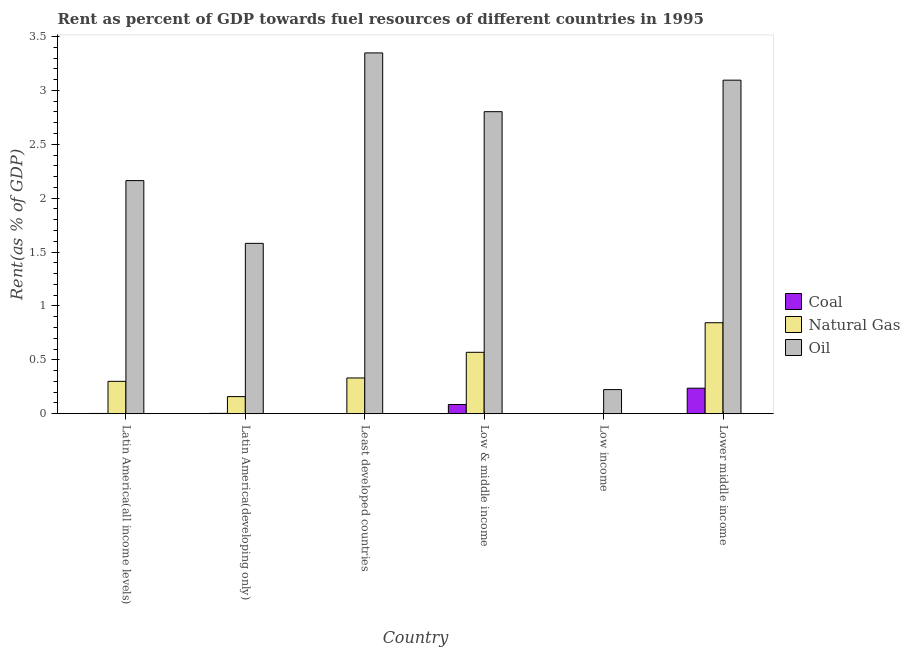How many different coloured bars are there?
Provide a short and direct response. 3. Are the number of bars on each tick of the X-axis equal?
Give a very brief answer. Yes. What is the rent towards coal in Latin America(all income levels)?
Give a very brief answer. 0. Across all countries, what is the maximum rent towards coal?
Your response must be concise. 0.24. Across all countries, what is the minimum rent towards natural gas?
Offer a very short reply. 3.1650228781704e-5. In which country was the rent towards coal maximum?
Provide a short and direct response. Lower middle income. What is the total rent towards oil in the graph?
Your answer should be compact. 13.21. What is the difference between the rent towards natural gas in Latin America(developing only) and that in Least developed countries?
Offer a very short reply. -0.17. What is the difference between the rent towards natural gas in Lower middle income and the rent towards coal in Latin America(developing only)?
Provide a succinct answer. 0.84. What is the average rent towards oil per country?
Ensure brevity in your answer.  2.2. What is the difference between the rent towards natural gas and rent towards coal in Low & middle income?
Provide a succinct answer. 0.48. What is the ratio of the rent towards oil in Latin America(all income levels) to that in Low & middle income?
Your response must be concise. 0.77. Is the difference between the rent towards coal in Latin America(all income levels) and Least developed countries greater than the difference between the rent towards oil in Latin America(all income levels) and Least developed countries?
Your response must be concise. Yes. What is the difference between the highest and the second highest rent towards oil?
Make the answer very short. 0.25. What is the difference between the highest and the lowest rent towards natural gas?
Offer a very short reply. 0.84. In how many countries, is the rent towards oil greater than the average rent towards oil taken over all countries?
Give a very brief answer. 3. What does the 3rd bar from the left in Latin America(all income levels) represents?
Give a very brief answer. Oil. What does the 1st bar from the right in Least developed countries represents?
Offer a very short reply. Oil. How many bars are there?
Your answer should be very brief. 18. How many countries are there in the graph?
Make the answer very short. 6. What is the difference between two consecutive major ticks on the Y-axis?
Provide a short and direct response. 0.5. Are the values on the major ticks of Y-axis written in scientific E-notation?
Provide a short and direct response. No. Does the graph contain any zero values?
Offer a terse response. No. Does the graph contain grids?
Your response must be concise. No. How many legend labels are there?
Your answer should be compact. 3. What is the title of the graph?
Your response must be concise. Rent as percent of GDP towards fuel resources of different countries in 1995. What is the label or title of the Y-axis?
Your response must be concise. Rent(as % of GDP). What is the Rent(as % of GDP) in Coal in Latin America(all income levels)?
Make the answer very short. 0. What is the Rent(as % of GDP) in Natural Gas in Latin America(all income levels)?
Provide a short and direct response. 0.3. What is the Rent(as % of GDP) in Oil in Latin America(all income levels)?
Give a very brief answer. 2.16. What is the Rent(as % of GDP) of Coal in Latin America(developing only)?
Give a very brief answer. 0. What is the Rent(as % of GDP) in Natural Gas in Latin America(developing only)?
Ensure brevity in your answer.  0.16. What is the Rent(as % of GDP) in Oil in Latin America(developing only)?
Provide a short and direct response. 1.58. What is the Rent(as % of GDP) of Coal in Least developed countries?
Keep it short and to the point. 0. What is the Rent(as % of GDP) of Natural Gas in Least developed countries?
Keep it short and to the point. 0.33. What is the Rent(as % of GDP) of Oil in Least developed countries?
Your answer should be compact. 3.35. What is the Rent(as % of GDP) of Coal in Low & middle income?
Keep it short and to the point. 0.09. What is the Rent(as % of GDP) of Natural Gas in Low & middle income?
Your answer should be very brief. 0.57. What is the Rent(as % of GDP) in Oil in Low & middle income?
Ensure brevity in your answer.  2.8. What is the Rent(as % of GDP) of Coal in Low income?
Provide a short and direct response. 0. What is the Rent(as % of GDP) of Natural Gas in Low income?
Offer a terse response. 3.1650228781704e-5. What is the Rent(as % of GDP) in Oil in Low income?
Ensure brevity in your answer.  0.22. What is the Rent(as % of GDP) in Coal in Lower middle income?
Ensure brevity in your answer.  0.24. What is the Rent(as % of GDP) in Natural Gas in Lower middle income?
Give a very brief answer. 0.84. What is the Rent(as % of GDP) of Oil in Lower middle income?
Ensure brevity in your answer.  3.1. Across all countries, what is the maximum Rent(as % of GDP) of Coal?
Keep it short and to the point. 0.24. Across all countries, what is the maximum Rent(as % of GDP) of Natural Gas?
Your response must be concise. 0.84. Across all countries, what is the maximum Rent(as % of GDP) in Oil?
Your response must be concise. 3.35. Across all countries, what is the minimum Rent(as % of GDP) in Coal?
Give a very brief answer. 0. Across all countries, what is the minimum Rent(as % of GDP) in Natural Gas?
Your answer should be compact. 3.1650228781704e-5. Across all countries, what is the minimum Rent(as % of GDP) in Oil?
Keep it short and to the point. 0.22. What is the total Rent(as % of GDP) in Coal in the graph?
Provide a short and direct response. 0.33. What is the total Rent(as % of GDP) in Natural Gas in the graph?
Offer a very short reply. 2.21. What is the total Rent(as % of GDP) in Oil in the graph?
Give a very brief answer. 13.21. What is the difference between the Rent(as % of GDP) in Coal in Latin America(all income levels) and that in Latin America(developing only)?
Your response must be concise. -0. What is the difference between the Rent(as % of GDP) of Natural Gas in Latin America(all income levels) and that in Latin America(developing only)?
Provide a short and direct response. 0.14. What is the difference between the Rent(as % of GDP) in Oil in Latin America(all income levels) and that in Latin America(developing only)?
Keep it short and to the point. 0.58. What is the difference between the Rent(as % of GDP) in Coal in Latin America(all income levels) and that in Least developed countries?
Provide a short and direct response. 0. What is the difference between the Rent(as % of GDP) in Natural Gas in Latin America(all income levels) and that in Least developed countries?
Your answer should be compact. -0.03. What is the difference between the Rent(as % of GDP) in Oil in Latin America(all income levels) and that in Least developed countries?
Provide a short and direct response. -1.18. What is the difference between the Rent(as % of GDP) of Coal in Latin America(all income levels) and that in Low & middle income?
Your answer should be very brief. -0.08. What is the difference between the Rent(as % of GDP) of Natural Gas in Latin America(all income levels) and that in Low & middle income?
Offer a terse response. -0.27. What is the difference between the Rent(as % of GDP) of Oil in Latin America(all income levels) and that in Low & middle income?
Your response must be concise. -0.64. What is the difference between the Rent(as % of GDP) of Coal in Latin America(all income levels) and that in Low income?
Your answer should be compact. 0. What is the difference between the Rent(as % of GDP) in Natural Gas in Latin America(all income levels) and that in Low income?
Give a very brief answer. 0.3. What is the difference between the Rent(as % of GDP) in Oil in Latin America(all income levels) and that in Low income?
Make the answer very short. 1.94. What is the difference between the Rent(as % of GDP) of Coal in Latin America(all income levels) and that in Lower middle income?
Give a very brief answer. -0.23. What is the difference between the Rent(as % of GDP) of Natural Gas in Latin America(all income levels) and that in Lower middle income?
Provide a short and direct response. -0.54. What is the difference between the Rent(as % of GDP) in Oil in Latin America(all income levels) and that in Lower middle income?
Provide a succinct answer. -0.93. What is the difference between the Rent(as % of GDP) in Coal in Latin America(developing only) and that in Least developed countries?
Your answer should be very brief. 0. What is the difference between the Rent(as % of GDP) of Natural Gas in Latin America(developing only) and that in Least developed countries?
Your response must be concise. -0.17. What is the difference between the Rent(as % of GDP) of Oil in Latin America(developing only) and that in Least developed countries?
Offer a terse response. -1.77. What is the difference between the Rent(as % of GDP) in Coal in Latin America(developing only) and that in Low & middle income?
Make the answer very short. -0.08. What is the difference between the Rent(as % of GDP) of Natural Gas in Latin America(developing only) and that in Low & middle income?
Ensure brevity in your answer.  -0.41. What is the difference between the Rent(as % of GDP) in Oil in Latin America(developing only) and that in Low & middle income?
Your answer should be compact. -1.22. What is the difference between the Rent(as % of GDP) in Coal in Latin America(developing only) and that in Low income?
Provide a short and direct response. 0. What is the difference between the Rent(as % of GDP) in Natural Gas in Latin America(developing only) and that in Low income?
Provide a succinct answer. 0.16. What is the difference between the Rent(as % of GDP) of Oil in Latin America(developing only) and that in Low income?
Your answer should be compact. 1.36. What is the difference between the Rent(as % of GDP) in Coal in Latin America(developing only) and that in Lower middle income?
Keep it short and to the point. -0.23. What is the difference between the Rent(as % of GDP) in Natural Gas in Latin America(developing only) and that in Lower middle income?
Give a very brief answer. -0.69. What is the difference between the Rent(as % of GDP) in Oil in Latin America(developing only) and that in Lower middle income?
Offer a very short reply. -1.51. What is the difference between the Rent(as % of GDP) of Coal in Least developed countries and that in Low & middle income?
Your answer should be very brief. -0.09. What is the difference between the Rent(as % of GDP) in Natural Gas in Least developed countries and that in Low & middle income?
Offer a very short reply. -0.24. What is the difference between the Rent(as % of GDP) in Oil in Least developed countries and that in Low & middle income?
Keep it short and to the point. 0.55. What is the difference between the Rent(as % of GDP) in Coal in Least developed countries and that in Low income?
Keep it short and to the point. -0. What is the difference between the Rent(as % of GDP) of Natural Gas in Least developed countries and that in Low income?
Make the answer very short. 0.33. What is the difference between the Rent(as % of GDP) in Oil in Least developed countries and that in Low income?
Ensure brevity in your answer.  3.12. What is the difference between the Rent(as % of GDP) of Coal in Least developed countries and that in Lower middle income?
Your answer should be very brief. -0.24. What is the difference between the Rent(as % of GDP) of Natural Gas in Least developed countries and that in Lower middle income?
Your answer should be very brief. -0.51. What is the difference between the Rent(as % of GDP) in Oil in Least developed countries and that in Lower middle income?
Offer a terse response. 0.25. What is the difference between the Rent(as % of GDP) of Coal in Low & middle income and that in Low income?
Keep it short and to the point. 0.08. What is the difference between the Rent(as % of GDP) in Natural Gas in Low & middle income and that in Low income?
Ensure brevity in your answer.  0.57. What is the difference between the Rent(as % of GDP) in Oil in Low & middle income and that in Low income?
Provide a short and direct response. 2.58. What is the difference between the Rent(as % of GDP) in Coal in Low & middle income and that in Lower middle income?
Offer a very short reply. -0.15. What is the difference between the Rent(as % of GDP) in Natural Gas in Low & middle income and that in Lower middle income?
Provide a succinct answer. -0.27. What is the difference between the Rent(as % of GDP) in Oil in Low & middle income and that in Lower middle income?
Make the answer very short. -0.29. What is the difference between the Rent(as % of GDP) of Coal in Low income and that in Lower middle income?
Provide a succinct answer. -0.24. What is the difference between the Rent(as % of GDP) of Natural Gas in Low income and that in Lower middle income?
Give a very brief answer. -0.84. What is the difference between the Rent(as % of GDP) of Oil in Low income and that in Lower middle income?
Offer a terse response. -2.87. What is the difference between the Rent(as % of GDP) of Coal in Latin America(all income levels) and the Rent(as % of GDP) of Natural Gas in Latin America(developing only)?
Your response must be concise. -0.16. What is the difference between the Rent(as % of GDP) of Coal in Latin America(all income levels) and the Rent(as % of GDP) of Oil in Latin America(developing only)?
Offer a very short reply. -1.58. What is the difference between the Rent(as % of GDP) in Natural Gas in Latin America(all income levels) and the Rent(as % of GDP) in Oil in Latin America(developing only)?
Give a very brief answer. -1.28. What is the difference between the Rent(as % of GDP) of Coal in Latin America(all income levels) and the Rent(as % of GDP) of Natural Gas in Least developed countries?
Provide a short and direct response. -0.33. What is the difference between the Rent(as % of GDP) in Coal in Latin America(all income levels) and the Rent(as % of GDP) in Oil in Least developed countries?
Provide a succinct answer. -3.35. What is the difference between the Rent(as % of GDP) in Natural Gas in Latin America(all income levels) and the Rent(as % of GDP) in Oil in Least developed countries?
Give a very brief answer. -3.05. What is the difference between the Rent(as % of GDP) in Coal in Latin America(all income levels) and the Rent(as % of GDP) in Natural Gas in Low & middle income?
Provide a short and direct response. -0.57. What is the difference between the Rent(as % of GDP) of Coal in Latin America(all income levels) and the Rent(as % of GDP) of Oil in Low & middle income?
Provide a succinct answer. -2.8. What is the difference between the Rent(as % of GDP) of Natural Gas in Latin America(all income levels) and the Rent(as % of GDP) of Oil in Low & middle income?
Your answer should be compact. -2.5. What is the difference between the Rent(as % of GDP) in Coal in Latin America(all income levels) and the Rent(as % of GDP) in Natural Gas in Low income?
Your response must be concise. 0. What is the difference between the Rent(as % of GDP) in Coal in Latin America(all income levels) and the Rent(as % of GDP) in Oil in Low income?
Ensure brevity in your answer.  -0.22. What is the difference between the Rent(as % of GDP) of Natural Gas in Latin America(all income levels) and the Rent(as % of GDP) of Oil in Low income?
Your response must be concise. 0.08. What is the difference between the Rent(as % of GDP) in Coal in Latin America(all income levels) and the Rent(as % of GDP) in Natural Gas in Lower middle income?
Provide a succinct answer. -0.84. What is the difference between the Rent(as % of GDP) in Coal in Latin America(all income levels) and the Rent(as % of GDP) in Oil in Lower middle income?
Ensure brevity in your answer.  -3.09. What is the difference between the Rent(as % of GDP) of Natural Gas in Latin America(all income levels) and the Rent(as % of GDP) of Oil in Lower middle income?
Offer a terse response. -2.79. What is the difference between the Rent(as % of GDP) in Coal in Latin America(developing only) and the Rent(as % of GDP) in Natural Gas in Least developed countries?
Ensure brevity in your answer.  -0.33. What is the difference between the Rent(as % of GDP) in Coal in Latin America(developing only) and the Rent(as % of GDP) in Oil in Least developed countries?
Offer a terse response. -3.34. What is the difference between the Rent(as % of GDP) of Natural Gas in Latin America(developing only) and the Rent(as % of GDP) of Oil in Least developed countries?
Keep it short and to the point. -3.19. What is the difference between the Rent(as % of GDP) in Coal in Latin America(developing only) and the Rent(as % of GDP) in Natural Gas in Low & middle income?
Provide a succinct answer. -0.57. What is the difference between the Rent(as % of GDP) of Coal in Latin America(developing only) and the Rent(as % of GDP) of Oil in Low & middle income?
Offer a very short reply. -2.8. What is the difference between the Rent(as % of GDP) in Natural Gas in Latin America(developing only) and the Rent(as % of GDP) in Oil in Low & middle income?
Offer a terse response. -2.64. What is the difference between the Rent(as % of GDP) in Coal in Latin America(developing only) and the Rent(as % of GDP) in Natural Gas in Low income?
Ensure brevity in your answer.  0. What is the difference between the Rent(as % of GDP) of Coal in Latin America(developing only) and the Rent(as % of GDP) of Oil in Low income?
Your answer should be very brief. -0.22. What is the difference between the Rent(as % of GDP) of Natural Gas in Latin America(developing only) and the Rent(as % of GDP) of Oil in Low income?
Your response must be concise. -0.06. What is the difference between the Rent(as % of GDP) of Coal in Latin America(developing only) and the Rent(as % of GDP) of Natural Gas in Lower middle income?
Make the answer very short. -0.84. What is the difference between the Rent(as % of GDP) of Coal in Latin America(developing only) and the Rent(as % of GDP) of Oil in Lower middle income?
Your answer should be compact. -3.09. What is the difference between the Rent(as % of GDP) in Natural Gas in Latin America(developing only) and the Rent(as % of GDP) in Oil in Lower middle income?
Offer a terse response. -2.94. What is the difference between the Rent(as % of GDP) in Coal in Least developed countries and the Rent(as % of GDP) in Natural Gas in Low & middle income?
Provide a short and direct response. -0.57. What is the difference between the Rent(as % of GDP) of Coal in Least developed countries and the Rent(as % of GDP) of Oil in Low & middle income?
Your response must be concise. -2.8. What is the difference between the Rent(as % of GDP) of Natural Gas in Least developed countries and the Rent(as % of GDP) of Oil in Low & middle income?
Make the answer very short. -2.47. What is the difference between the Rent(as % of GDP) in Coal in Least developed countries and the Rent(as % of GDP) in Natural Gas in Low income?
Your response must be concise. 0. What is the difference between the Rent(as % of GDP) in Coal in Least developed countries and the Rent(as % of GDP) in Oil in Low income?
Your response must be concise. -0.22. What is the difference between the Rent(as % of GDP) in Natural Gas in Least developed countries and the Rent(as % of GDP) in Oil in Low income?
Your answer should be very brief. 0.11. What is the difference between the Rent(as % of GDP) in Coal in Least developed countries and the Rent(as % of GDP) in Natural Gas in Lower middle income?
Provide a succinct answer. -0.84. What is the difference between the Rent(as % of GDP) in Coal in Least developed countries and the Rent(as % of GDP) in Oil in Lower middle income?
Ensure brevity in your answer.  -3.09. What is the difference between the Rent(as % of GDP) of Natural Gas in Least developed countries and the Rent(as % of GDP) of Oil in Lower middle income?
Your answer should be very brief. -2.76. What is the difference between the Rent(as % of GDP) in Coal in Low & middle income and the Rent(as % of GDP) in Natural Gas in Low income?
Ensure brevity in your answer.  0.09. What is the difference between the Rent(as % of GDP) in Coal in Low & middle income and the Rent(as % of GDP) in Oil in Low income?
Provide a succinct answer. -0.14. What is the difference between the Rent(as % of GDP) in Natural Gas in Low & middle income and the Rent(as % of GDP) in Oil in Low income?
Make the answer very short. 0.35. What is the difference between the Rent(as % of GDP) of Coal in Low & middle income and the Rent(as % of GDP) of Natural Gas in Lower middle income?
Your response must be concise. -0.76. What is the difference between the Rent(as % of GDP) of Coal in Low & middle income and the Rent(as % of GDP) of Oil in Lower middle income?
Provide a succinct answer. -3.01. What is the difference between the Rent(as % of GDP) of Natural Gas in Low & middle income and the Rent(as % of GDP) of Oil in Lower middle income?
Make the answer very short. -2.53. What is the difference between the Rent(as % of GDP) in Coal in Low income and the Rent(as % of GDP) in Natural Gas in Lower middle income?
Offer a very short reply. -0.84. What is the difference between the Rent(as % of GDP) of Coal in Low income and the Rent(as % of GDP) of Oil in Lower middle income?
Give a very brief answer. -3.09. What is the difference between the Rent(as % of GDP) of Natural Gas in Low income and the Rent(as % of GDP) of Oil in Lower middle income?
Ensure brevity in your answer.  -3.1. What is the average Rent(as % of GDP) of Coal per country?
Your answer should be compact. 0.06. What is the average Rent(as % of GDP) of Natural Gas per country?
Make the answer very short. 0.37. What is the average Rent(as % of GDP) of Oil per country?
Make the answer very short. 2.2. What is the difference between the Rent(as % of GDP) of Coal and Rent(as % of GDP) of Natural Gas in Latin America(all income levels)?
Your response must be concise. -0.3. What is the difference between the Rent(as % of GDP) in Coal and Rent(as % of GDP) in Oil in Latin America(all income levels)?
Your response must be concise. -2.16. What is the difference between the Rent(as % of GDP) in Natural Gas and Rent(as % of GDP) in Oil in Latin America(all income levels)?
Give a very brief answer. -1.86. What is the difference between the Rent(as % of GDP) of Coal and Rent(as % of GDP) of Natural Gas in Latin America(developing only)?
Make the answer very short. -0.16. What is the difference between the Rent(as % of GDP) of Coal and Rent(as % of GDP) of Oil in Latin America(developing only)?
Offer a very short reply. -1.58. What is the difference between the Rent(as % of GDP) in Natural Gas and Rent(as % of GDP) in Oil in Latin America(developing only)?
Provide a succinct answer. -1.42. What is the difference between the Rent(as % of GDP) in Coal and Rent(as % of GDP) in Natural Gas in Least developed countries?
Offer a very short reply. -0.33. What is the difference between the Rent(as % of GDP) in Coal and Rent(as % of GDP) in Oil in Least developed countries?
Offer a terse response. -3.35. What is the difference between the Rent(as % of GDP) in Natural Gas and Rent(as % of GDP) in Oil in Least developed countries?
Your response must be concise. -3.02. What is the difference between the Rent(as % of GDP) of Coal and Rent(as % of GDP) of Natural Gas in Low & middle income?
Your response must be concise. -0.48. What is the difference between the Rent(as % of GDP) of Coal and Rent(as % of GDP) of Oil in Low & middle income?
Ensure brevity in your answer.  -2.72. What is the difference between the Rent(as % of GDP) of Natural Gas and Rent(as % of GDP) of Oil in Low & middle income?
Ensure brevity in your answer.  -2.23. What is the difference between the Rent(as % of GDP) in Coal and Rent(as % of GDP) in Natural Gas in Low income?
Ensure brevity in your answer.  0. What is the difference between the Rent(as % of GDP) of Coal and Rent(as % of GDP) of Oil in Low income?
Offer a terse response. -0.22. What is the difference between the Rent(as % of GDP) of Natural Gas and Rent(as % of GDP) of Oil in Low income?
Offer a very short reply. -0.22. What is the difference between the Rent(as % of GDP) in Coal and Rent(as % of GDP) in Natural Gas in Lower middle income?
Offer a terse response. -0.61. What is the difference between the Rent(as % of GDP) of Coal and Rent(as % of GDP) of Oil in Lower middle income?
Give a very brief answer. -2.86. What is the difference between the Rent(as % of GDP) of Natural Gas and Rent(as % of GDP) of Oil in Lower middle income?
Keep it short and to the point. -2.25. What is the ratio of the Rent(as % of GDP) of Coal in Latin America(all income levels) to that in Latin America(developing only)?
Keep it short and to the point. 0.75. What is the ratio of the Rent(as % of GDP) of Natural Gas in Latin America(all income levels) to that in Latin America(developing only)?
Provide a short and direct response. 1.89. What is the ratio of the Rent(as % of GDP) of Oil in Latin America(all income levels) to that in Latin America(developing only)?
Provide a succinct answer. 1.37. What is the ratio of the Rent(as % of GDP) in Coal in Latin America(all income levels) to that in Least developed countries?
Provide a succinct answer. 5.73. What is the ratio of the Rent(as % of GDP) in Natural Gas in Latin America(all income levels) to that in Least developed countries?
Provide a succinct answer. 0.91. What is the ratio of the Rent(as % of GDP) of Oil in Latin America(all income levels) to that in Least developed countries?
Provide a succinct answer. 0.65. What is the ratio of the Rent(as % of GDP) of Coal in Latin America(all income levels) to that in Low & middle income?
Your response must be concise. 0.03. What is the ratio of the Rent(as % of GDP) of Natural Gas in Latin America(all income levels) to that in Low & middle income?
Keep it short and to the point. 0.53. What is the ratio of the Rent(as % of GDP) in Oil in Latin America(all income levels) to that in Low & middle income?
Offer a very short reply. 0.77. What is the ratio of the Rent(as % of GDP) in Coal in Latin America(all income levels) to that in Low income?
Your answer should be very brief. 1.79. What is the ratio of the Rent(as % of GDP) of Natural Gas in Latin America(all income levels) to that in Low income?
Your answer should be compact. 9497.84. What is the ratio of the Rent(as % of GDP) of Oil in Latin America(all income levels) to that in Low income?
Offer a very short reply. 9.66. What is the ratio of the Rent(as % of GDP) of Coal in Latin America(all income levels) to that in Lower middle income?
Your response must be concise. 0.01. What is the ratio of the Rent(as % of GDP) in Natural Gas in Latin America(all income levels) to that in Lower middle income?
Offer a very short reply. 0.36. What is the ratio of the Rent(as % of GDP) in Oil in Latin America(all income levels) to that in Lower middle income?
Your answer should be compact. 0.7. What is the ratio of the Rent(as % of GDP) in Coal in Latin America(developing only) to that in Least developed countries?
Your answer should be very brief. 7.66. What is the ratio of the Rent(as % of GDP) in Natural Gas in Latin America(developing only) to that in Least developed countries?
Provide a short and direct response. 0.48. What is the ratio of the Rent(as % of GDP) of Oil in Latin America(developing only) to that in Least developed countries?
Offer a very short reply. 0.47. What is the ratio of the Rent(as % of GDP) of Coal in Latin America(developing only) to that in Low & middle income?
Provide a succinct answer. 0.04. What is the ratio of the Rent(as % of GDP) in Natural Gas in Latin America(developing only) to that in Low & middle income?
Offer a terse response. 0.28. What is the ratio of the Rent(as % of GDP) of Oil in Latin America(developing only) to that in Low & middle income?
Your answer should be compact. 0.56. What is the ratio of the Rent(as % of GDP) in Coal in Latin America(developing only) to that in Low income?
Make the answer very short. 2.4. What is the ratio of the Rent(as % of GDP) of Natural Gas in Latin America(developing only) to that in Low income?
Your answer should be compact. 5026.56. What is the ratio of the Rent(as % of GDP) of Oil in Latin America(developing only) to that in Low income?
Offer a very short reply. 7.06. What is the ratio of the Rent(as % of GDP) of Coal in Latin America(developing only) to that in Lower middle income?
Offer a terse response. 0.02. What is the ratio of the Rent(as % of GDP) in Natural Gas in Latin America(developing only) to that in Lower middle income?
Your answer should be compact. 0.19. What is the ratio of the Rent(as % of GDP) of Oil in Latin America(developing only) to that in Lower middle income?
Offer a terse response. 0.51. What is the ratio of the Rent(as % of GDP) in Coal in Least developed countries to that in Low & middle income?
Provide a succinct answer. 0.01. What is the ratio of the Rent(as % of GDP) of Natural Gas in Least developed countries to that in Low & middle income?
Offer a very short reply. 0.58. What is the ratio of the Rent(as % of GDP) in Oil in Least developed countries to that in Low & middle income?
Provide a succinct answer. 1.19. What is the ratio of the Rent(as % of GDP) in Coal in Least developed countries to that in Low income?
Offer a terse response. 0.31. What is the ratio of the Rent(as % of GDP) of Natural Gas in Least developed countries to that in Low income?
Your answer should be compact. 1.05e+04. What is the ratio of the Rent(as % of GDP) of Oil in Least developed countries to that in Low income?
Your response must be concise. 14.95. What is the ratio of the Rent(as % of GDP) of Coal in Least developed countries to that in Lower middle income?
Ensure brevity in your answer.  0. What is the ratio of the Rent(as % of GDP) in Natural Gas in Least developed countries to that in Lower middle income?
Offer a very short reply. 0.39. What is the ratio of the Rent(as % of GDP) of Oil in Least developed countries to that in Lower middle income?
Your response must be concise. 1.08. What is the ratio of the Rent(as % of GDP) in Coal in Low & middle income to that in Low income?
Your answer should be compact. 56.73. What is the ratio of the Rent(as % of GDP) in Natural Gas in Low & middle income to that in Low income?
Offer a terse response. 1.80e+04. What is the ratio of the Rent(as % of GDP) in Oil in Low & middle income to that in Low income?
Your answer should be compact. 12.51. What is the ratio of the Rent(as % of GDP) of Coal in Low & middle income to that in Lower middle income?
Your answer should be compact. 0.36. What is the ratio of the Rent(as % of GDP) of Natural Gas in Low & middle income to that in Lower middle income?
Provide a succinct answer. 0.68. What is the ratio of the Rent(as % of GDP) in Oil in Low & middle income to that in Lower middle income?
Keep it short and to the point. 0.91. What is the ratio of the Rent(as % of GDP) of Coal in Low income to that in Lower middle income?
Your answer should be compact. 0.01. What is the ratio of the Rent(as % of GDP) in Oil in Low income to that in Lower middle income?
Provide a short and direct response. 0.07. What is the difference between the highest and the second highest Rent(as % of GDP) of Coal?
Give a very brief answer. 0.15. What is the difference between the highest and the second highest Rent(as % of GDP) of Natural Gas?
Your answer should be very brief. 0.27. What is the difference between the highest and the second highest Rent(as % of GDP) in Oil?
Offer a terse response. 0.25. What is the difference between the highest and the lowest Rent(as % of GDP) of Coal?
Give a very brief answer. 0.24. What is the difference between the highest and the lowest Rent(as % of GDP) of Natural Gas?
Keep it short and to the point. 0.84. What is the difference between the highest and the lowest Rent(as % of GDP) in Oil?
Keep it short and to the point. 3.12. 